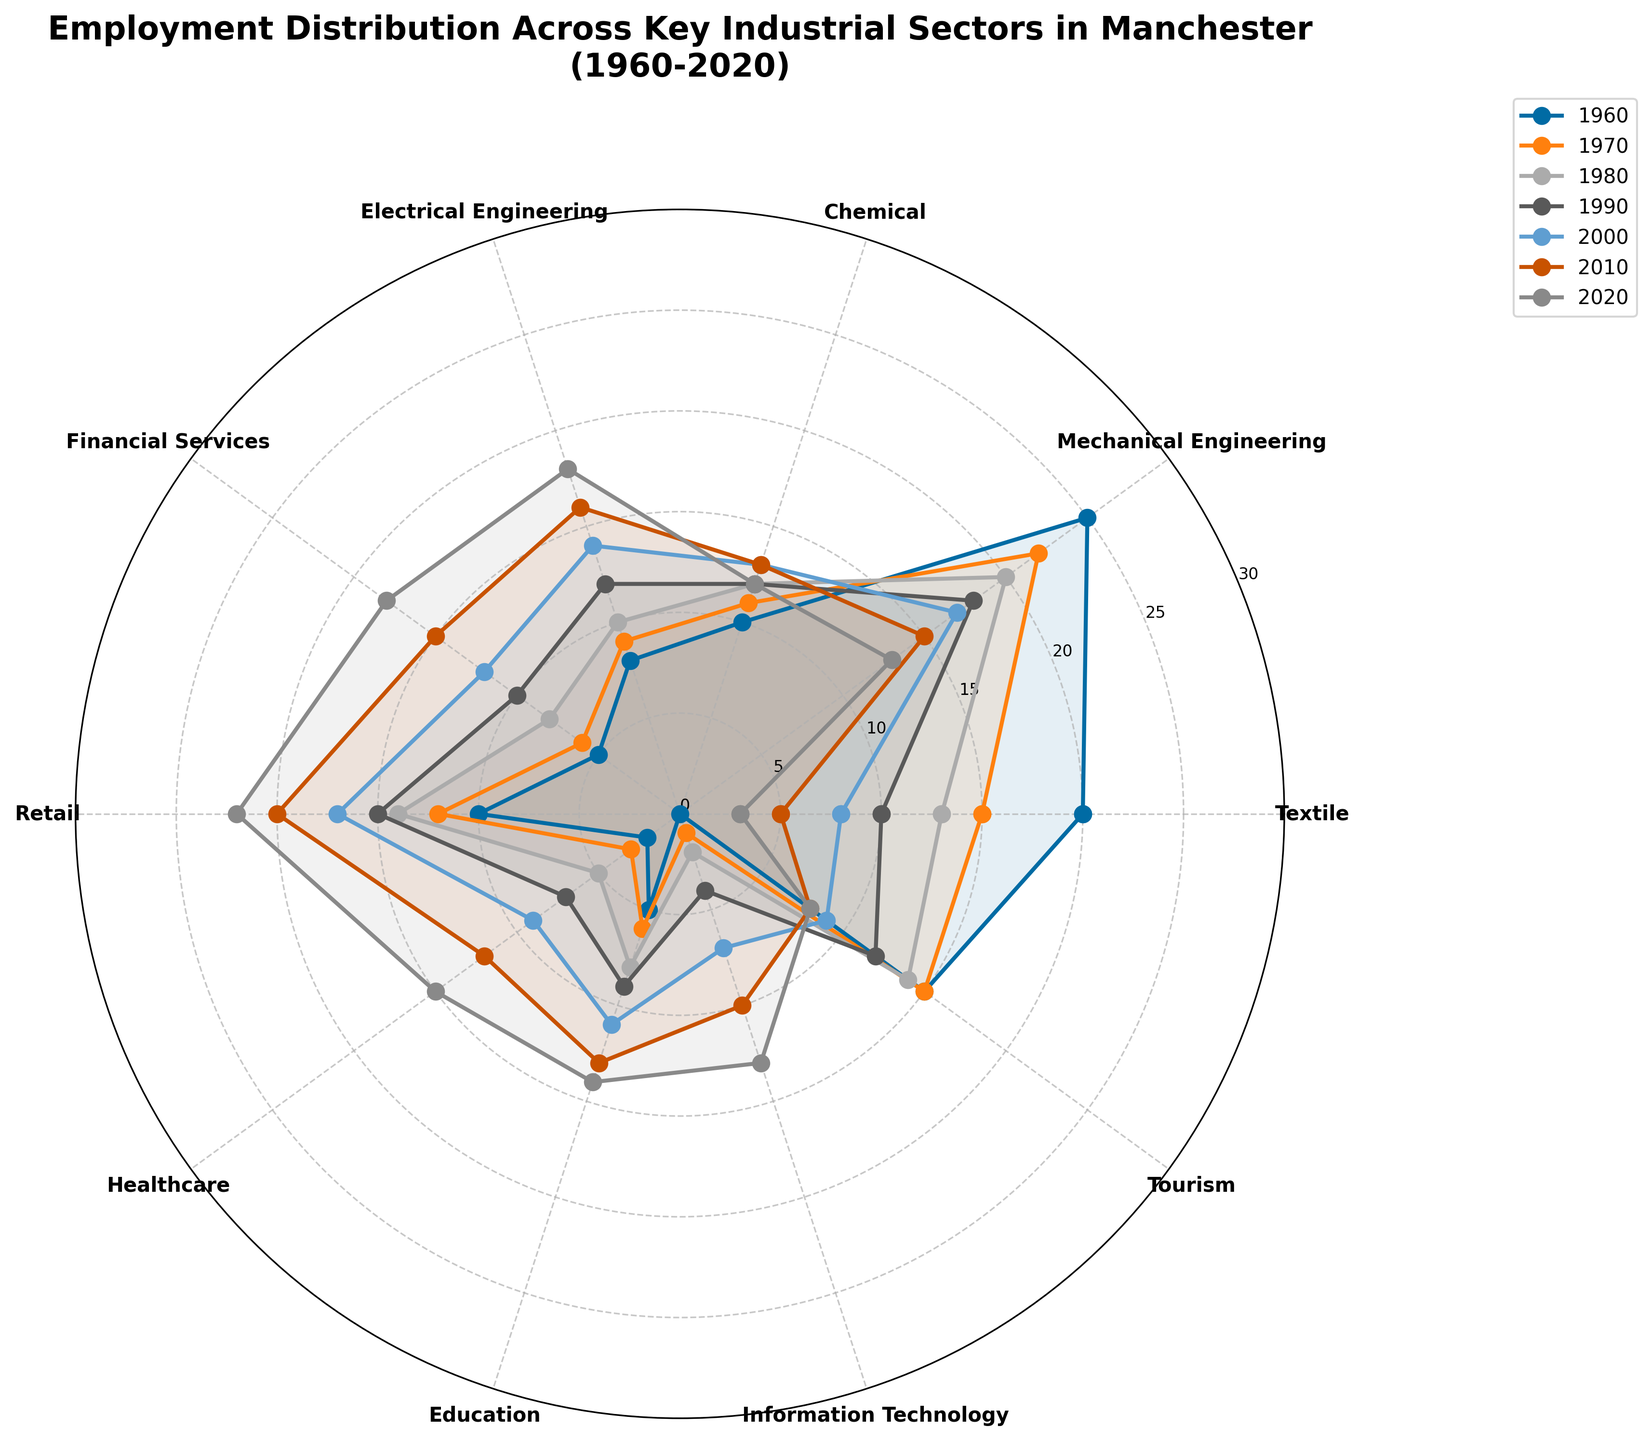What is the title of the figure? The title is located at the top of the plot and provides an overview of the data analyzed.
Answer: Employment Distribution Across Key Industrial Sectors in Manchester (1960-2020) Which sector had the highest employment distribution in 1960? By checking the angles corresponding to sectors and observing their values in 1960, Mechanical Engineering had the highest segment.
Answer: Mechanical Engineering How did employment in the Textile sector change from 1960 to 2020? Compare the values for the Textile sector in 1960 and 2020; it decreased from 20 to 3.
Answer: Decreased What sector saw the most significant increase from 1960 to 2020? By comparing all sectors' values between 1960 and 2020, IT saw the most significant increase, from 0 to 13.
Answer: Information Technology Which two sectors had equal employment in 2000? Locate the intersection points for the 2000 year line across the sectors; Financial Services and Healthcare both have an employment value of 12.
Answer: Financial Services and Healthcare What is the average employment distribution for the Healthcare sector across all decades? Add the employment values for Healthcare across all decades (2+3+5+7+9+12+15) and divide by 7 (number of decades). The average is (53/7 ≈ 7.57).
Answer: Approximately 7.57 Was there any sector where employment distribution remained constant across multiple decades? By examining the year lines for any flat, consistent segments, the Tourism sector had a consistent value of 15 from 1960 to 1970.
Answer: Tourism In 1990, which sector had greater employment: Chemical or Electrical Engineering? Comparing the values for both sectors in 1990, Electrical Engineering (12) had greater employment than Chemical (12).
Answer: Electrical Engineering Is there a sector that saw a consistent upward trend from 1960 to 2020? By checking each sector's values in every decade and looking for a consistent increase, Electrical Engineering showed an increase from 8 to 18.
Answer: Electrical Engineering Which sector had the least employment distribution in 1980? Locate the smallest segment value for 1980, which corresponds to Healthcare (5).
Answer: Healthcare 